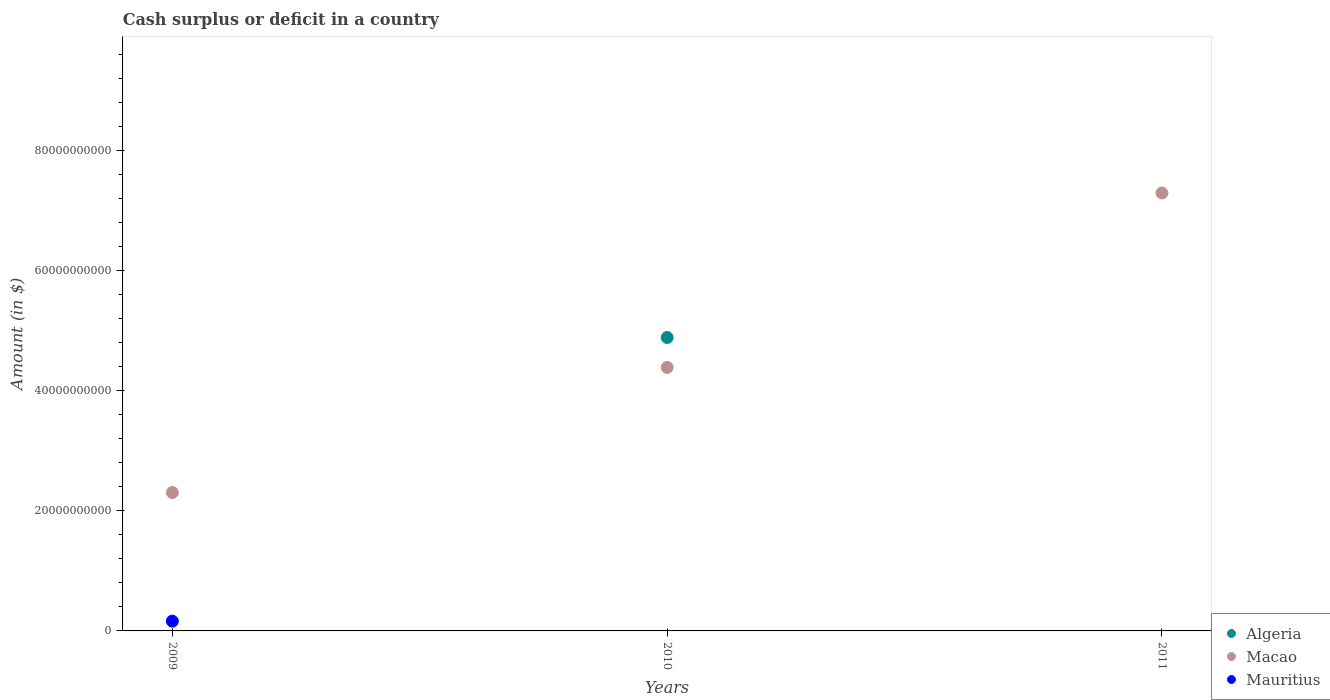What is the amount of cash surplus or deficit in Algeria in 2009?
Your response must be concise. 0. Across all years, what is the maximum amount of cash surplus or deficit in Macao?
Provide a succinct answer. 7.29e+1. Across all years, what is the minimum amount of cash surplus or deficit in Macao?
Offer a terse response. 2.30e+1. What is the total amount of cash surplus or deficit in Algeria in the graph?
Your answer should be very brief. 4.88e+1. What is the difference between the amount of cash surplus or deficit in Macao in 2009 and that in 2011?
Ensure brevity in your answer.  -4.98e+1. What is the difference between the amount of cash surplus or deficit in Mauritius in 2011 and the amount of cash surplus or deficit in Macao in 2010?
Keep it short and to the point. -4.39e+1. What is the average amount of cash surplus or deficit in Macao per year?
Ensure brevity in your answer.  4.66e+1. In the year 2010, what is the difference between the amount of cash surplus or deficit in Algeria and amount of cash surplus or deficit in Macao?
Keep it short and to the point. 4.97e+09. What is the ratio of the amount of cash surplus or deficit in Macao in 2009 to that in 2010?
Provide a short and direct response. 0.53. Is the amount of cash surplus or deficit in Macao in 2009 less than that in 2010?
Provide a short and direct response. Yes. What is the difference between the highest and the second highest amount of cash surplus or deficit in Macao?
Make the answer very short. 2.90e+1. What is the difference between the highest and the lowest amount of cash surplus or deficit in Macao?
Keep it short and to the point. 4.98e+1. In how many years, is the amount of cash surplus or deficit in Mauritius greater than the average amount of cash surplus or deficit in Mauritius taken over all years?
Provide a succinct answer. 1. Is the sum of the amount of cash surplus or deficit in Macao in 2009 and 2010 greater than the maximum amount of cash surplus or deficit in Mauritius across all years?
Your answer should be compact. Yes. Is it the case that in every year, the sum of the amount of cash surplus or deficit in Algeria and amount of cash surplus or deficit in Mauritius  is greater than the amount of cash surplus or deficit in Macao?
Your response must be concise. No. Does the amount of cash surplus or deficit in Macao monotonically increase over the years?
Offer a very short reply. Yes. How many dotlines are there?
Your answer should be very brief. 3. What is the difference between two consecutive major ticks on the Y-axis?
Give a very brief answer. 2.00e+1. Where does the legend appear in the graph?
Give a very brief answer. Bottom right. How many legend labels are there?
Ensure brevity in your answer.  3. What is the title of the graph?
Offer a terse response. Cash surplus or deficit in a country. What is the label or title of the Y-axis?
Offer a very short reply. Amount (in $). What is the Amount (in $) in Macao in 2009?
Provide a short and direct response. 2.30e+1. What is the Amount (in $) in Mauritius in 2009?
Ensure brevity in your answer.  1.62e+09. What is the Amount (in $) of Algeria in 2010?
Keep it short and to the point. 4.88e+1. What is the Amount (in $) in Macao in 2010?
Your answer should be very brief. 4.39e+1. What is the Amount (in $) of Mauritius in 2010?
Your answer should be very brief. 0. What is the Amount (in $) of Algeria in 2011?
Your answer should be very brief. 0. What is the Amount (in $) in Macao in 2011?
Provide a succinct answer. 7.29e+1. Across all years, what is the maximum Amount (in $) of Algeria?
Offer a very short reply. 4.88e+1. Across all years, what is the maximum Amount (in $) of Macao?
Keep it short and to the point. 7.29e+1. Across all years, what is the maximum Amount (in $) of Mauritius?
Keep it short and to the point. 1.62e+09. Across all years, what is the minimum Amount (in $) of Algeria?
Keep it short and to the point. 0. Across all years, what is the minimum Amount (in $) of Macao?
Your response must be concise. 2.30e+1. What is the total Amount (in $) of Algeria in the graph?
Provide a succinct answer. 4.88e+1. What is the total Amount (in $) of Macao in the graph?
Ensure brevity in your answer.  1.40e+11. What is the total Amount (in $) in Mauritius in the graph?
Your answer should be very brief. 1.62e+09. What is the difference between the Amount (in $) of Macao in 2009 and that in 2010?
Ensure brevity in your answer.  -2.08e+1. What is the difference between the Amount (in $) in Macao in 2009 and that in 2011?
Make the answer very short. -4.98e+1. What is the difference between the Amount (in $) in Macao in 2010 and that in 2011?
Provide a short and direct response. -2.90e+1. What is the difference between the Amount (in $) in Algeria in 2010 and the Amount (in $) in Macao in 2011?
Provide a succinct answer. -2.41e+1. What is the average Amount (in $) in Algeria per year?
Give a very brief answer. 1.63e+1. What is the average Amount (in $) in Macao per year?
Give a very brief answer. 4.66e+1. What is the average Amount (in $) in Mauritius per year?
Give a very brief answer. 5.41e+08. In the year 2009, what is the difference between the Amount (in $) of Macao and Amount (in $) of Mauritius?
Your answer should be very brief. 2.14e+1. In the year 2010, what is the difference between the Amount (in $) in Algeria and Amount (in $) in Macao?
Provide a succinct answer. 4.97e+09. What is the ratio of the Amount (in $) in Macao in 2009 to that in 2010?
Ensure brevity in your answer.  0.53. What is the ratio of the Amount (in $) in Macao in 2009 to that in 2011?
Your answer should be very brief. 0.32. What is the ratio of the Amount (in $) in Macao in 2010 to that in 2011?
Provide a succinct answer. 0.6. What is the difference between the highest and the second highest Amount (in $) in Macao?
Give a very brief answer. 2.90e+1. What is the difference between the highest and the lowest Amount (in $) in Algeria?
Offer a terse response. 4.88e+1. What is the difference between the highest and the lowest Amount (in $) in Macao?
Provide a short and direct response. 4.98e+1. What is the difference between the highest and the lowest Amount (in $) in Mauritius?
Your answer should be compact. 1.62e+09. 